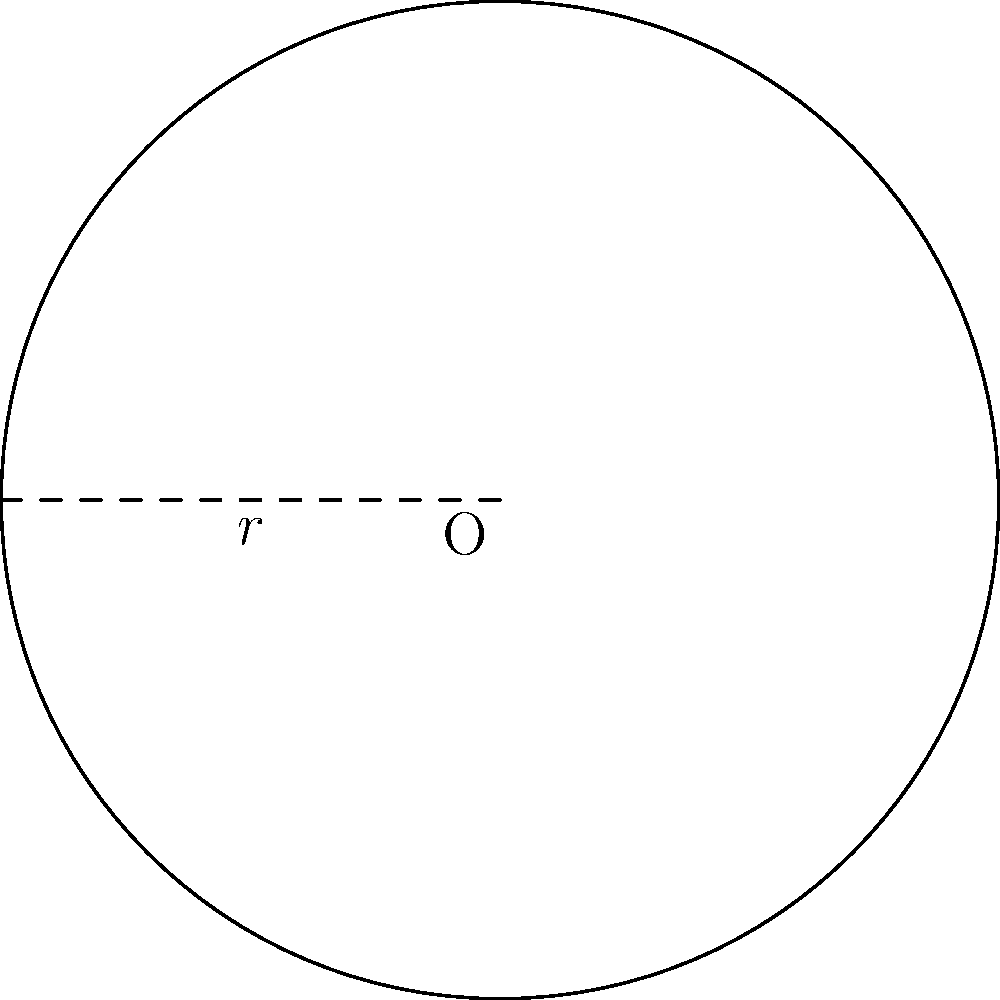As part of a new patient-friendly packaging initiative, you're designing a circular pill container. If the radius of the container's base is 3 cm, what is the area of the circular surface? Round your answer to two decimal places. To calculate the area of a circular surface, we use the formula:

$$A = \pi r^2$$

Where:
$A$ = area of the circle
$\pi$ = pi (approximately 3.14159)
$r$ = radius of the circle

Given:
$r = 3$ cm

Step 1: Substitute the values into the formula
$$A = \pi (3\text{ cm})^2$$

Step 2: Calculate the square of the radius
$$A = \pi (9\text{ cm}^2)$$

Step 3: Multiply by π
$$A = 28.27433\text{ cm}^2$$

Step 4: Round to two decimal places
$$A ≈ 28.27\text{ cm}^2$$
Answer: $28.27\text{ cm}^2$ 